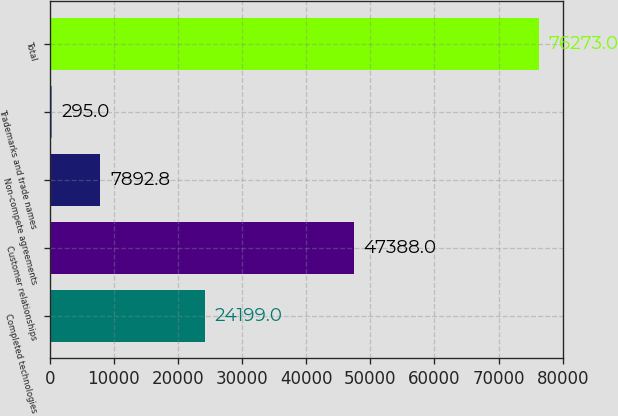<chart> <loc_0><loc_0><loc_500><loc_500><bar_chart><fcel>Completed technologies<fcel>Customer relationships<fcel>Non-compete agreements<fcel>Trademarks and trade names<fcel>Total<nl><fcel>24199<fcel>47388<fcel>7892.8<fcel>295<fcel>76273<nl></chart> 